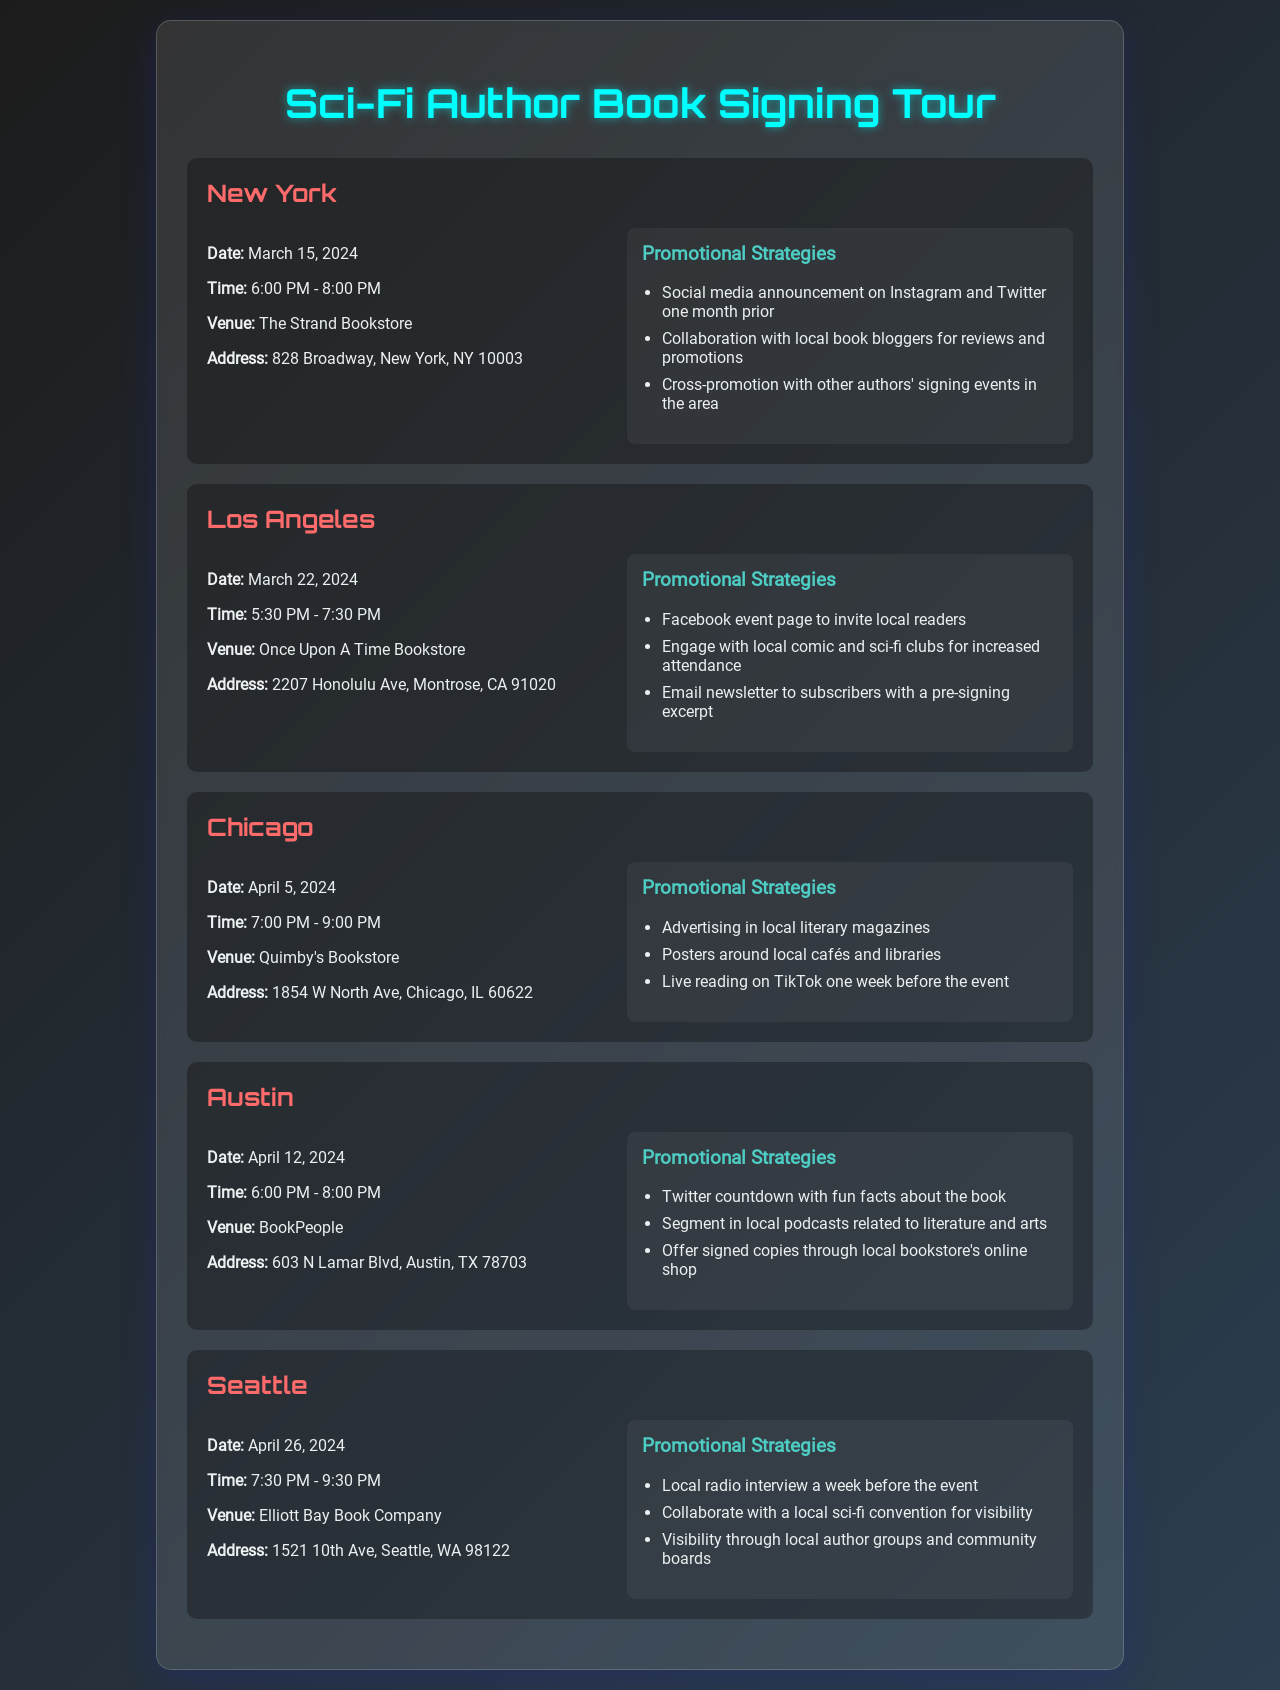What city is the first book signing event in? The first event listed in the document is in New York.
Answer: New York What is the date of the Los Angeles signing? The document states that the Los Angeles signing is scheduled for March 22, 2024.
Answer: March 22, 2024 What is the venue for the Chicago event? The venue for the Chicago signing event is Quimby's Bookstore.
Answer: Quimby's Bookstore How long is the Seattle signing scheduled to last? The Seattle signing is from 7:30 PM to 9:30 PM, making it a duration of 2 hours.
Answer: 2 hours Which city has a signing event that occurs in April? The events scheduled for April are in Chicago, Austin, and Seattle.
Answer: Chicago, Austin, Seattle What promotional strategy is used for the New York event? One of the promotional strategies for New York includes a social media announcement on Instagram and Twitter.
Answer: Social media announcement How many book signing events are scheduled in total? The document lists a total of five book signing events.
Answer: Five What is the main focus of the promotional strategies mentioned? The promotional strategies focus on creating awareness and attracting attendees to the events.
Answer: Awareness What time does the Austin signing event begin? The Austin signing event starts at 6:00 PM, as stated in the document.
Answer: 6:00 PM 